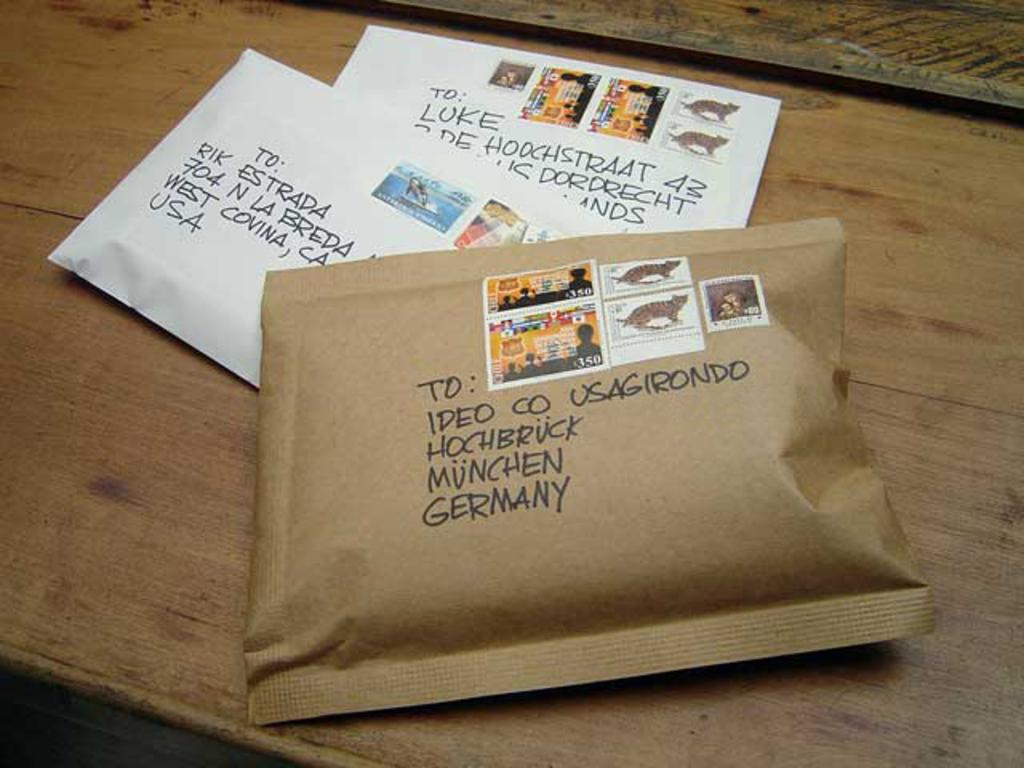<image>
Render a clear and concise summary of the photo. Packages with postage ready to be mailed to Germany and the USA. 